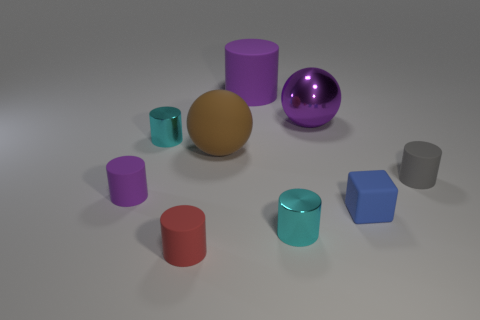Subtract all cyan cylinders. How many cylinders are left? 4 Subtract all tiny cyan shiny cylinders. How many cylinders are left? 4 Subtract all green cylinders. Subtract all blue cubes. How many cylinders are left? 6 Subtract all cylinders. How many objects are left? 3 Add 5 small gray rubber cubes. How many small gray rubber cubes exist? 5 Subtract 2 purple cylinders. How many objects are left? 7 Subtract all big brown shiny cubes. Subtract all gray matte cylinders. How many objects are left? 8 Add 6 gray matte cylinders. How many gray matte cylinders are left? 7 